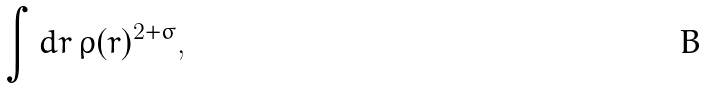<formula> <loc_0><loc_0><loc_500><loc_500>\int d { r } \, \rho ( { r } ) ^ { 2 + \sigma } ,</formula> 